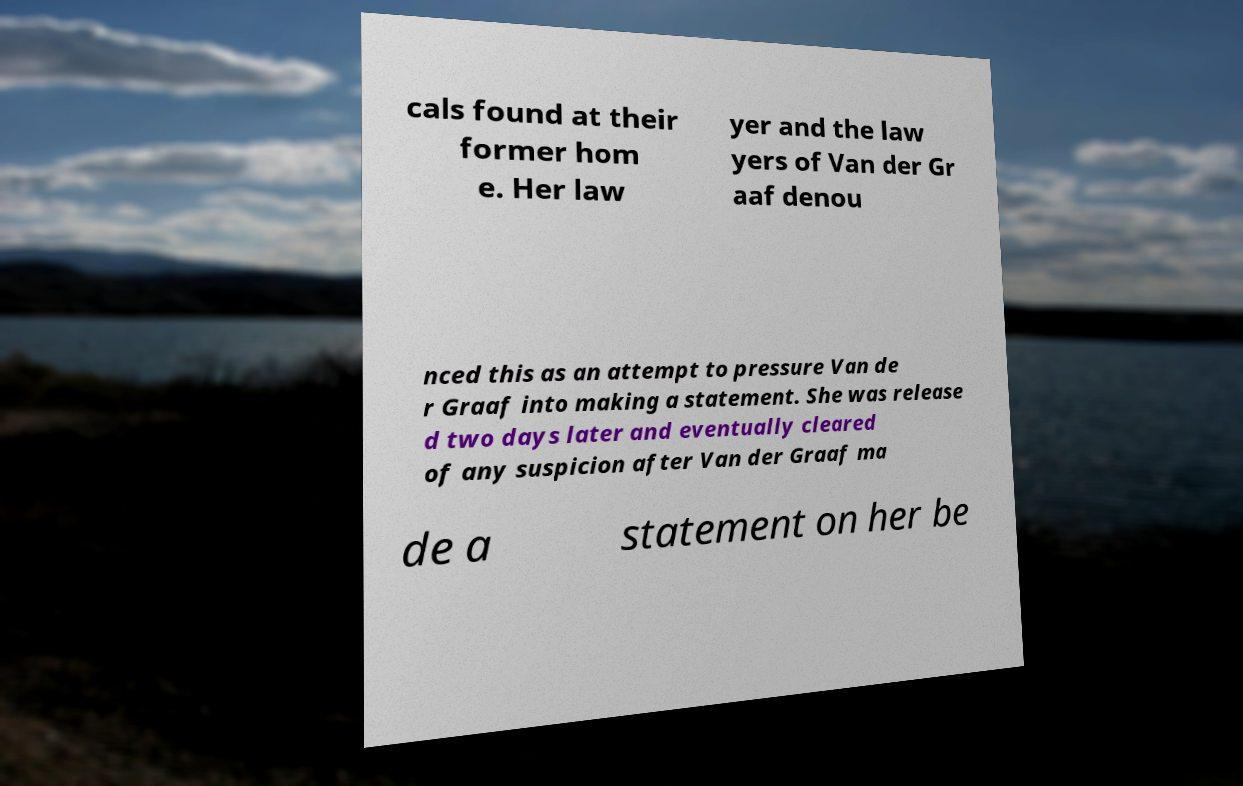There's text embedded in this image that I need extracted. Can you transcribe it verbatim? cals found at their former hom e. Her law yer and the law yers of Van der Gr aaf denou nced this as an attempt to pressure Van de r Graaf into making a statement. She was release d two days later and eventually cleared of any suspicion after Van der Graaf ma de a statement on her be 